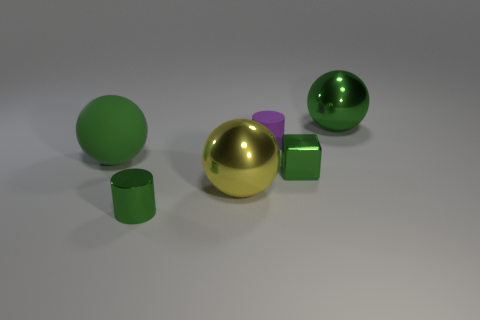There is a green ball that is the same material as the cube; what size is it?
Offer a terse response. Large. There is a green sphere that is on the left side of the green sphere that is right of the green sphere left of the green metallic sphere; what is its material?
Your response must be concise. Rubber. There is a large metallic thing that is the same color as the tiny block; what shape is it?
Give a very brief answer. Sphere. There is a sphere that is on the left side of the large yellow sphere; what is it made of?
Ensure brevity in your answer.  Rubber. There is a big sphere that is both in front of the tiny purple matte cylinder and behind the small block; what material is it?
Your answer should be very brief. Rubber. Does the green sphere left of the purple object have the same size as the green cylinder?
Give a very brief answer. No. The block is what color?
Keep it short and to the point. Green. Is there another small block made of the same material as the block?
Offer a terse response. No. Is there a big yellow object that is behind the large object to the left of the cylinder in front of the big green matte ball?
Offer a very short reply. No. There is a rubber ball; are there any metal objects on the left side of it?
Offer a terse response. No. 